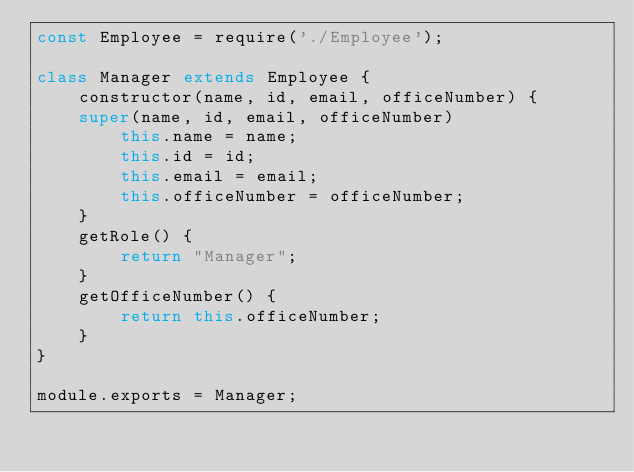Convert code to text. <code><loc_0><loc_0><loc_500><loc_500><_JavaScript_>const Employee = require('./Employee');

class Manager extends Employee {
    constructor(name, id, email, officeNumber) {
    super(name, id, email, officeNumber)
        this.name = name;
        this.id = id;
        this.email = email;
        this.officeNumber = officeNumber;
    }
    getRole() {
        return "Manager";
    }
    getOfficeNumber() {
        return this.officeNumber;
    } 
}

module.exports = Manager;</code> 